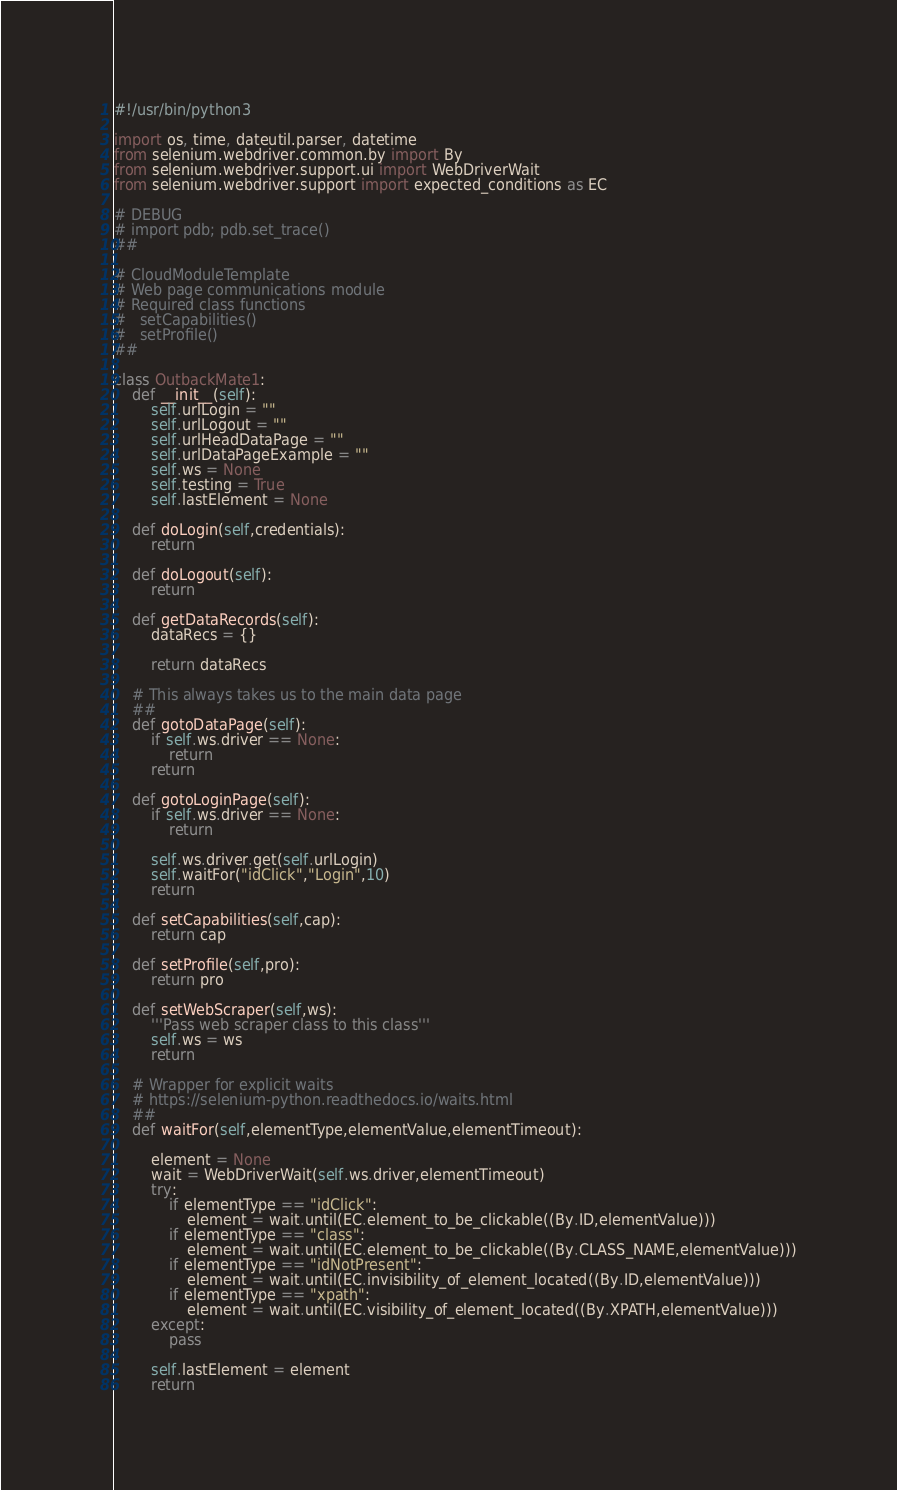<code> <loc_0><loc_0><loc_500><loc_500><_Python_>#!/usr/bin/python3

import os, time, dateutil.parser, datetime
from selenium.webdriver.common.by import By
from selenium.webdriver.support.ui import WebDriverWait
from selenium.webdriver.support import expected_conditions as EC

# DEBUG
# import pdb; pdb.set_trace()
##

# CloudModuleTemplate
# Web page communications module
# Required class functions
#   setCapabilities()
#   setProfile()
##

class OutbackMate1:
    def __init__(self):
        self.urlLogin = ""
        self.urlLogout = ""
        self.urlHeadDataPage = ""
        self.urlDataPageExample = ""
        self.ws = None
        self.testing = True
        self.lastElement = None

    def doLogin(self,credentials):
        return

    def doLogout(self):
        return

    def getDataRecords(self):
        dataRecs = {}

        return dataRecs

    # This always takes us to the main data page
    ##
    def gotoDataPage(self):
        if self.ws.driver == None:
            return
        return

    def gotoLoginPage(self):
        if self.ws.driver == None:
            return

        self.ws.driver.get(self.urlLogin)
        self.waitFor("idClick","Login",10)
        return

    def setCapabilities(self,cap):
        return cap

    def setProfile(self,pro):
        return pro

    def setWebScraper(self,ws):
        '''Pass web scraper class to this class'''
        self.ws = ws
        return

    # Wrapper for explicit waits
    # https://selenium-python.readthedocs.io/waits.html
    ##
    def waitFor(self,elementType,elementValue,elementTimeout):

        element = None
        wait = WebDriverWait(self.ws.driver,elementTimeout)
        try:
            if elementType == "idClick":
                element = wait.until(EC.element_to_be_clickable((By.ID,elementValue)))
            if elementType == "class":
                element = wait.until(EC.element_to_be_clickable((By.CLASS_NAME,elementValue)))
            if elementType == "idNotPresent":
                element = wait.until(EC.invisibility_of_element_located((By.ID,elementValue)))
            if elementType == "xpath":
                element = wait.until(EC.visibility_of_element_located((By.XPATH,elementValue)))
        except:
            pass

        self.lastElement = element
        return

</code> 